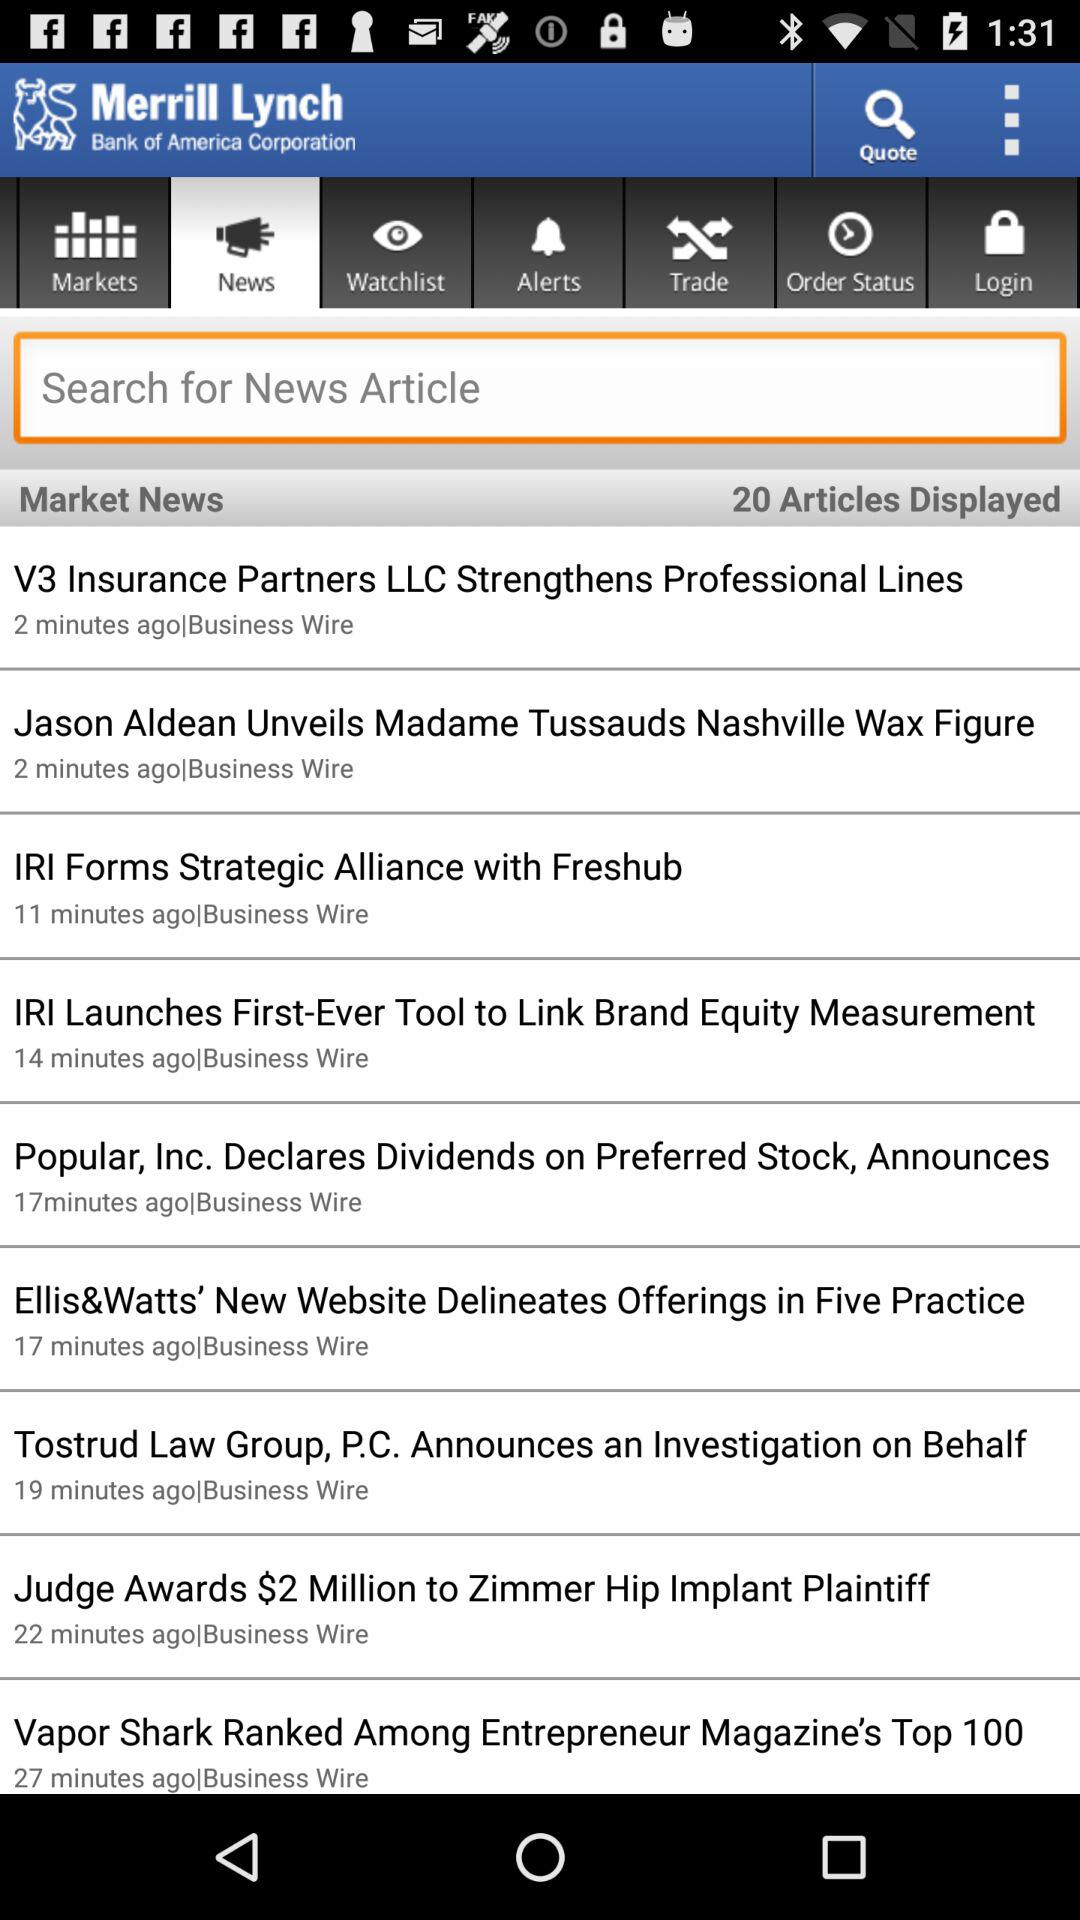How much is awarded to "Zimmer Hip Implant Plaintiff"? The awarded money is $2 million to "Zimmer Hip Implant Plaintiff". 